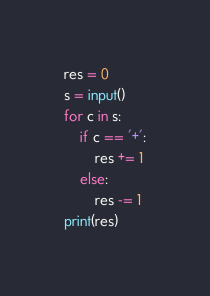Convert code to text. <code><loc_0><loc_0><loc_500><loc_500><_Python_>res = 0
s = input()
for c in s:
    if c == '+':
        res += 1
    else:
        res -= 1
print(res)</code> 